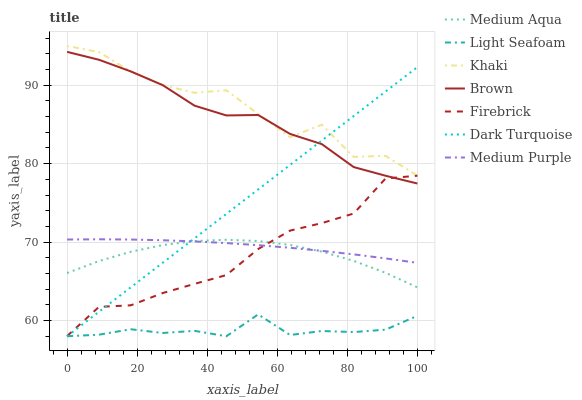Does Dark Turquoise have the minimum area under the curve?
Answer yes or no. No. Does Dark Turquoise have the maximum area under the curve?
Answer yes or no. No. Is Khaki the smoothest?
Answer yes or no. No. Is Dark Turquoise the roughest?
Answer yes or no. No. Does Khaki have the lowest value?
Answer yes or no. No. Does Dark Turquoise have the highest value?
Answer yes or no. No. Is Light Seafoam less than Khaki?
Answer yes or no. Yes. Is Medium Purple greater than Light Seafoam?
Answer yes or no. Yes. Does Light Seafoam intersect Khaki?
Answer yes or no. No. 